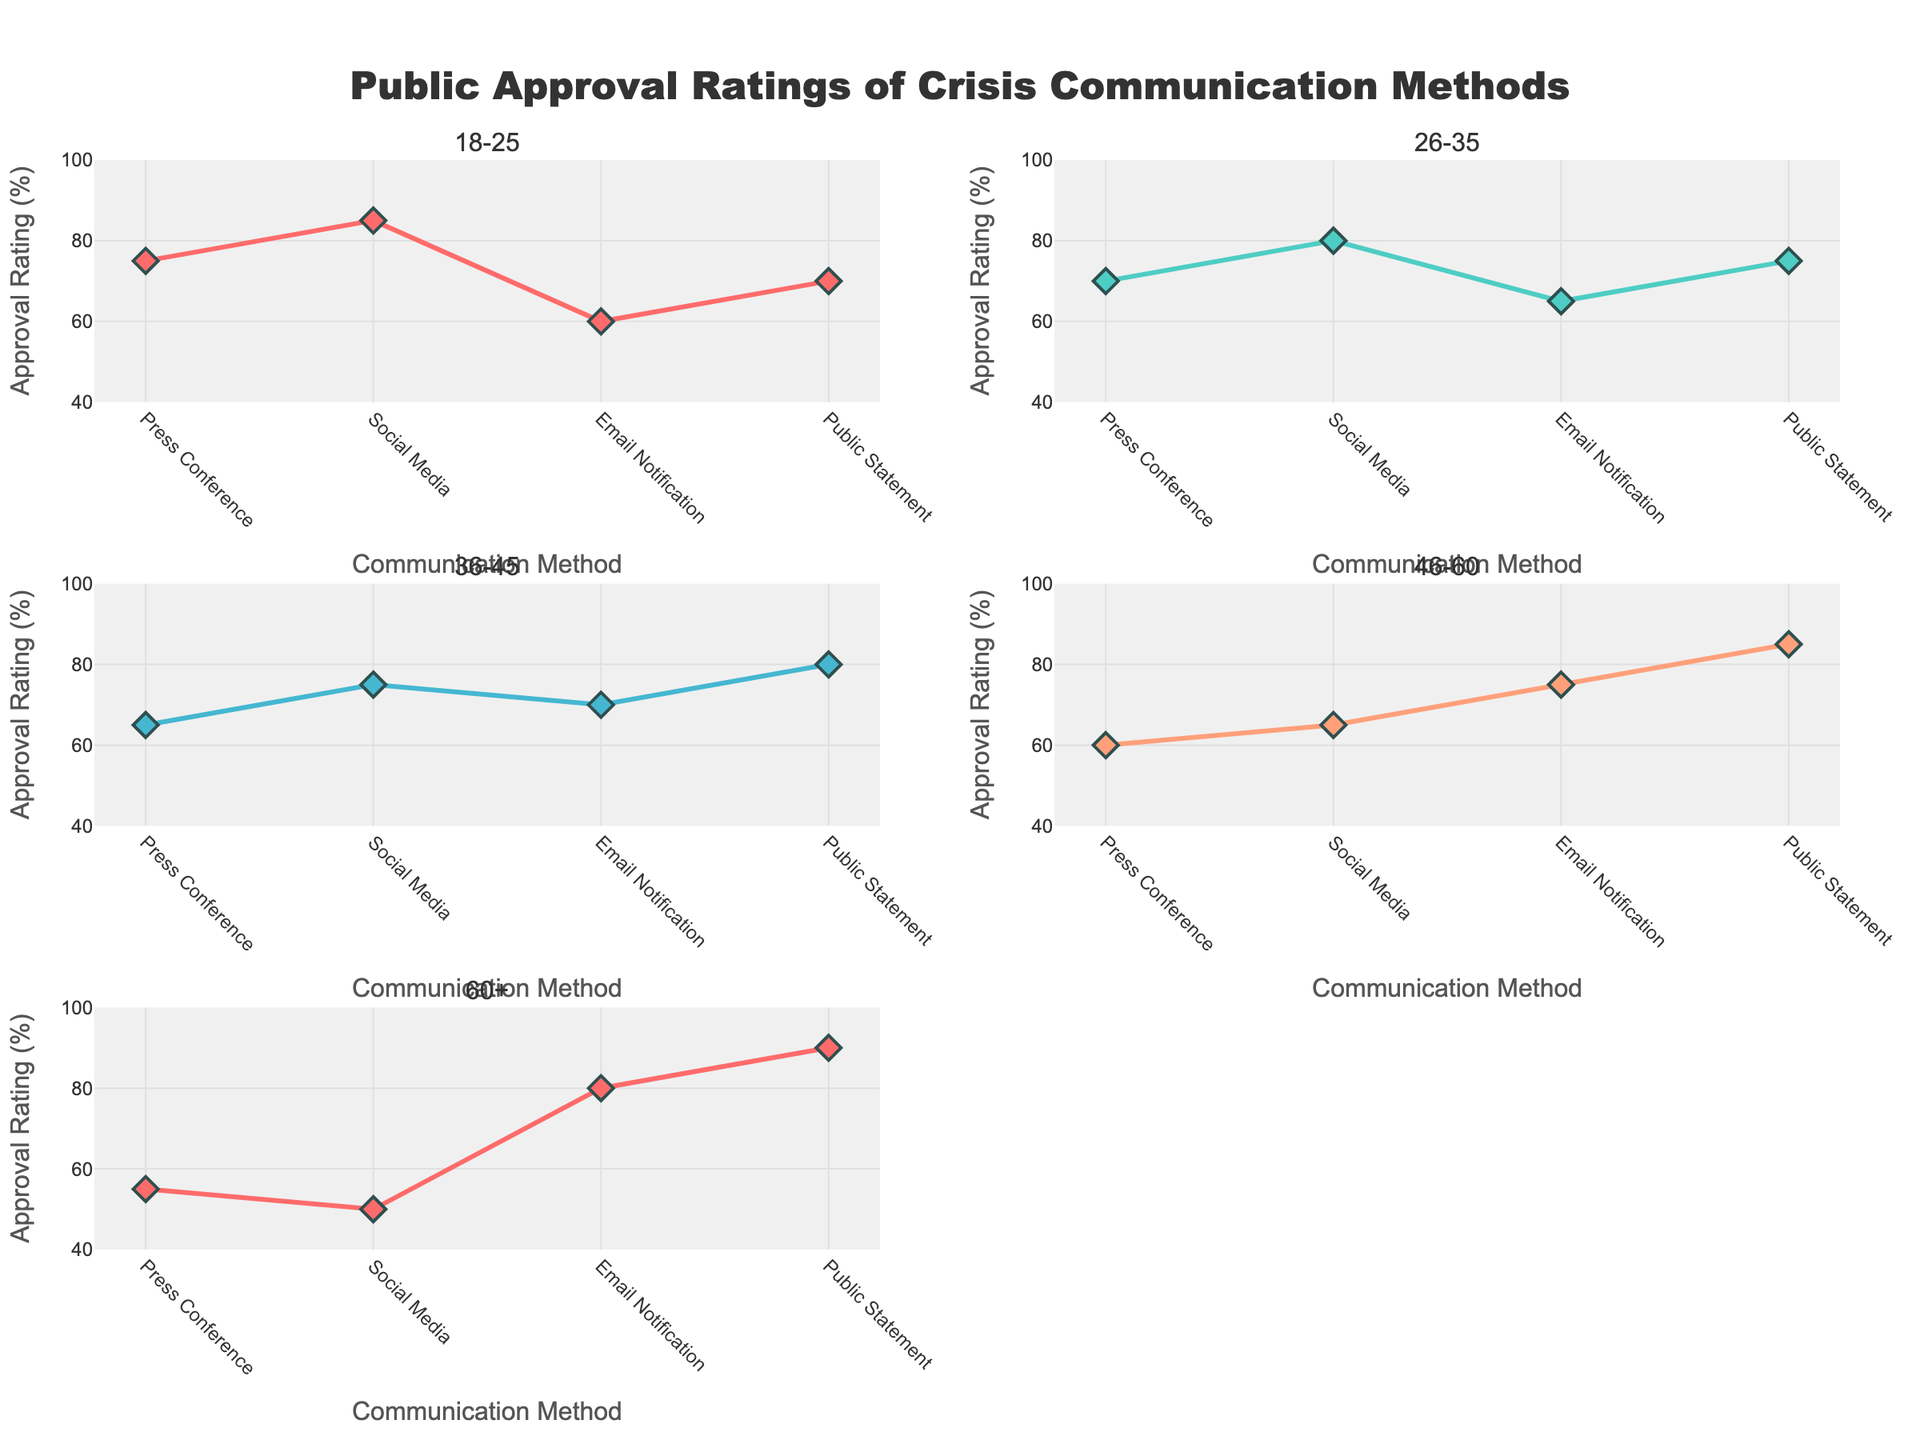How many unique communication methods are shown in each scatter plot? There are four communication methods depicted in each of the scatter plots: Press Conference, Social Media, Email Notification, and Public Statement. You can identify these by looking at the x-axis that lists these methods.
Answer: 4 What demographic group has the highest overall approval rating for any communication method? By inspecting each subplot, the 60+ demographic group has the highest approval rating, which is 90 for Public Statement. You can verify this by comparing the y-values in all subplots.
Answer: 60+ Which communication method has the highest approval rating among the 18-25 demographic group? By looking at the subplot for the 18-25 group, Social Media has the highest approval rating at 85%. You can identify this by checking the highest y-value in that subplot.
Answer: Social Media Which demographic group has the lowest approval rating for Social Media? By examining the y-values corresponding to Social Media in each subplot, the 60+ demographic group has the lowest approval rating for Social Media at 50%. This is the lowest y-value among all subplots for this method.
Answer: 60+ What is the difference in approval rating for Press Conference between the 18-25 and 60+ demographic groups? The approval rating for Press Conference is 75 for the 18-25 group and 55 for the 60+ group. The difference is calculated as 75 - 55.
Answer: 20 Which communication method shows the most consistent approval ratings across all demographic groups? By comparing the range and variability of y-values for each communication method across subplots, Public Statement has the most consistent approval ratings, with values ranging between 70 and 90.
Answer: Public Statement What is the average approval rating for Email Notification across all demographic groups? The approval ratings for Email Notification are 60 (18-25), 65 (26-35), 70 (36-45), 75 (46-60), and 80 (60+). The average is calculated as (60 + 65 + 70 + 75 + 80) / 5 = 70.
Answer: 70 Which demographic group has a higher approval rating for Email Notification than for any other communication method? By examining each subplot, the 60+ demographic group has an approval rating highest for Email Notification, which is 80, compared to other methods in the same group.
Answer: 60+ Is the approval rating for Social Media higher than for Press Conference across all demographic groups? By comparing the y-values of Social Media and Press Conference in each subplot: 85 > 75 (18-25), 80 > 70 (26-35), 75 > 65 (36-45), 65 > 60 (46-60), 50 < 55 (60+). Since Social Media rating is not higher in the 60+ group, the answer is no.
Answer: No 